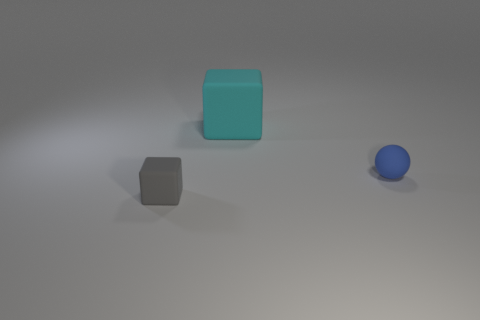Add 2 spheres. How many objects exist? 5 Subtract all blocks. How many objects are left? 1 Add 2 small blue things. How many small blue things are left? 3 Add 1 purple cylinders. How many purple cylinders exist? 1 Subtract 0 purple cylinders. How many objects are left? 3 Subtract all cyan matte objects. Subtract all small blue matte objects. How many objects are left? 1 